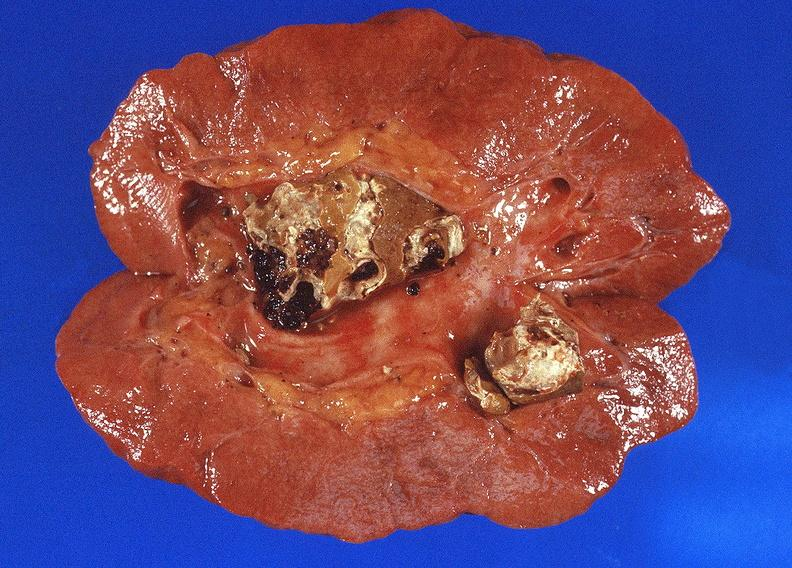what does this image show?
Answer the question using a single word or phrase. Staghorn calculi in renal pelvis 